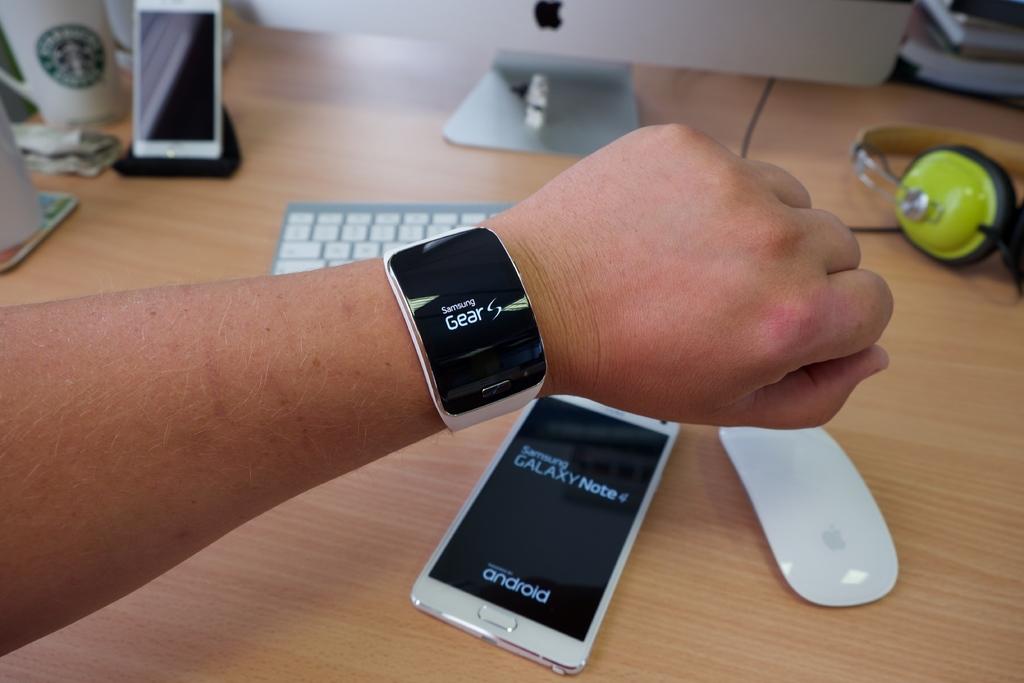What type of watch is this, seen on the watch face?
Ensure brevity in your answer.  Samsung gear. What type of operating system does the phone havea?
Make the answer very short. Android. 